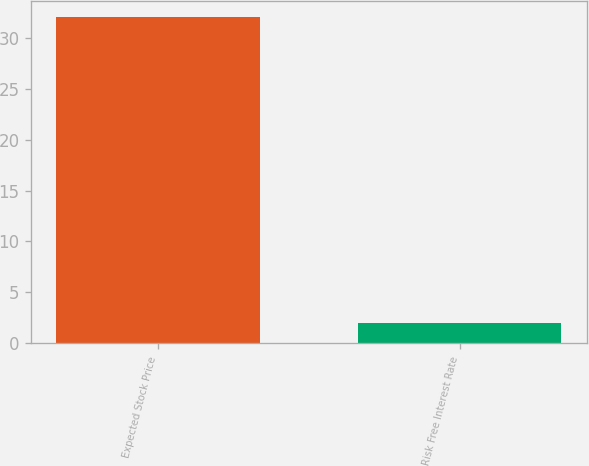Convert chart to OTSL. <chart><loc_0><loc_0><loc_500><loc_500><bar_chart><fcel>Expected Stock Price<fcel>Risk Free Interest Rate<nl><fcel>32<fcel>2<nl></chart> 